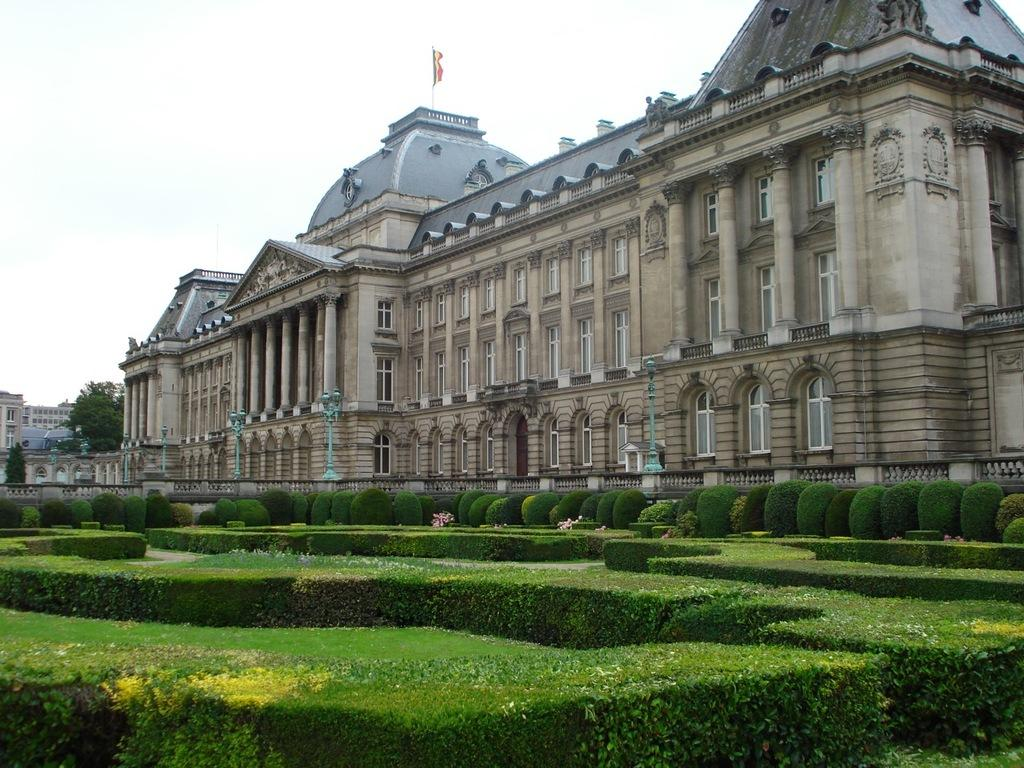What type of living organisms can be seen in the image? Plants can be seen in the image. Where are the plants located in relation to the building? The plants are in front of a building. What is visible at the top of the image? The sky is visible at the top of the image. What company does the writer work for in the image? There is no writer or company present in the image; it features plants in front of a building with a visible sky. 